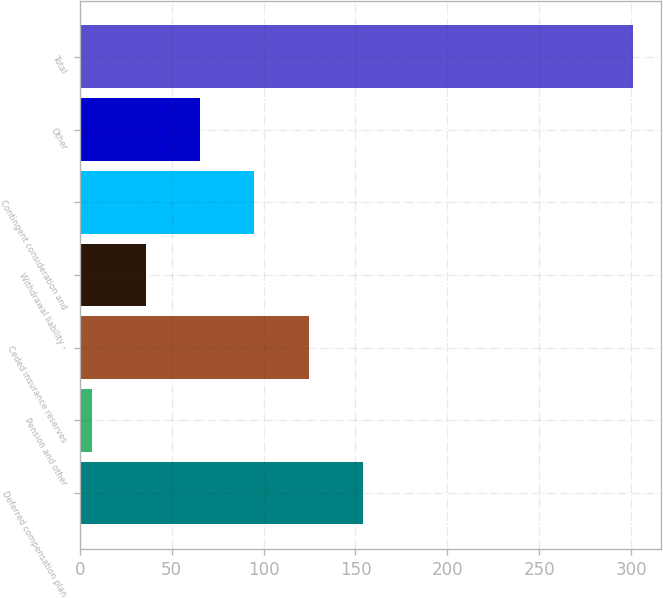<chart> <loc_0><loc_0><loc_500><loc_500><bar_chart><fcel>Deferred compensation plan<fcel>Pension and other<fcel>Ceded insurance reserves<fcel>Withdrawal liability -<fcel>Contingent consideration and<fcel>Other<fcel>Total<nl><fcel>153.95<fcel>6.7<fcel>124.5<fcel>36.15<fcel>95.05<fcel>65.6<fcel>301.2<nl></chart> 